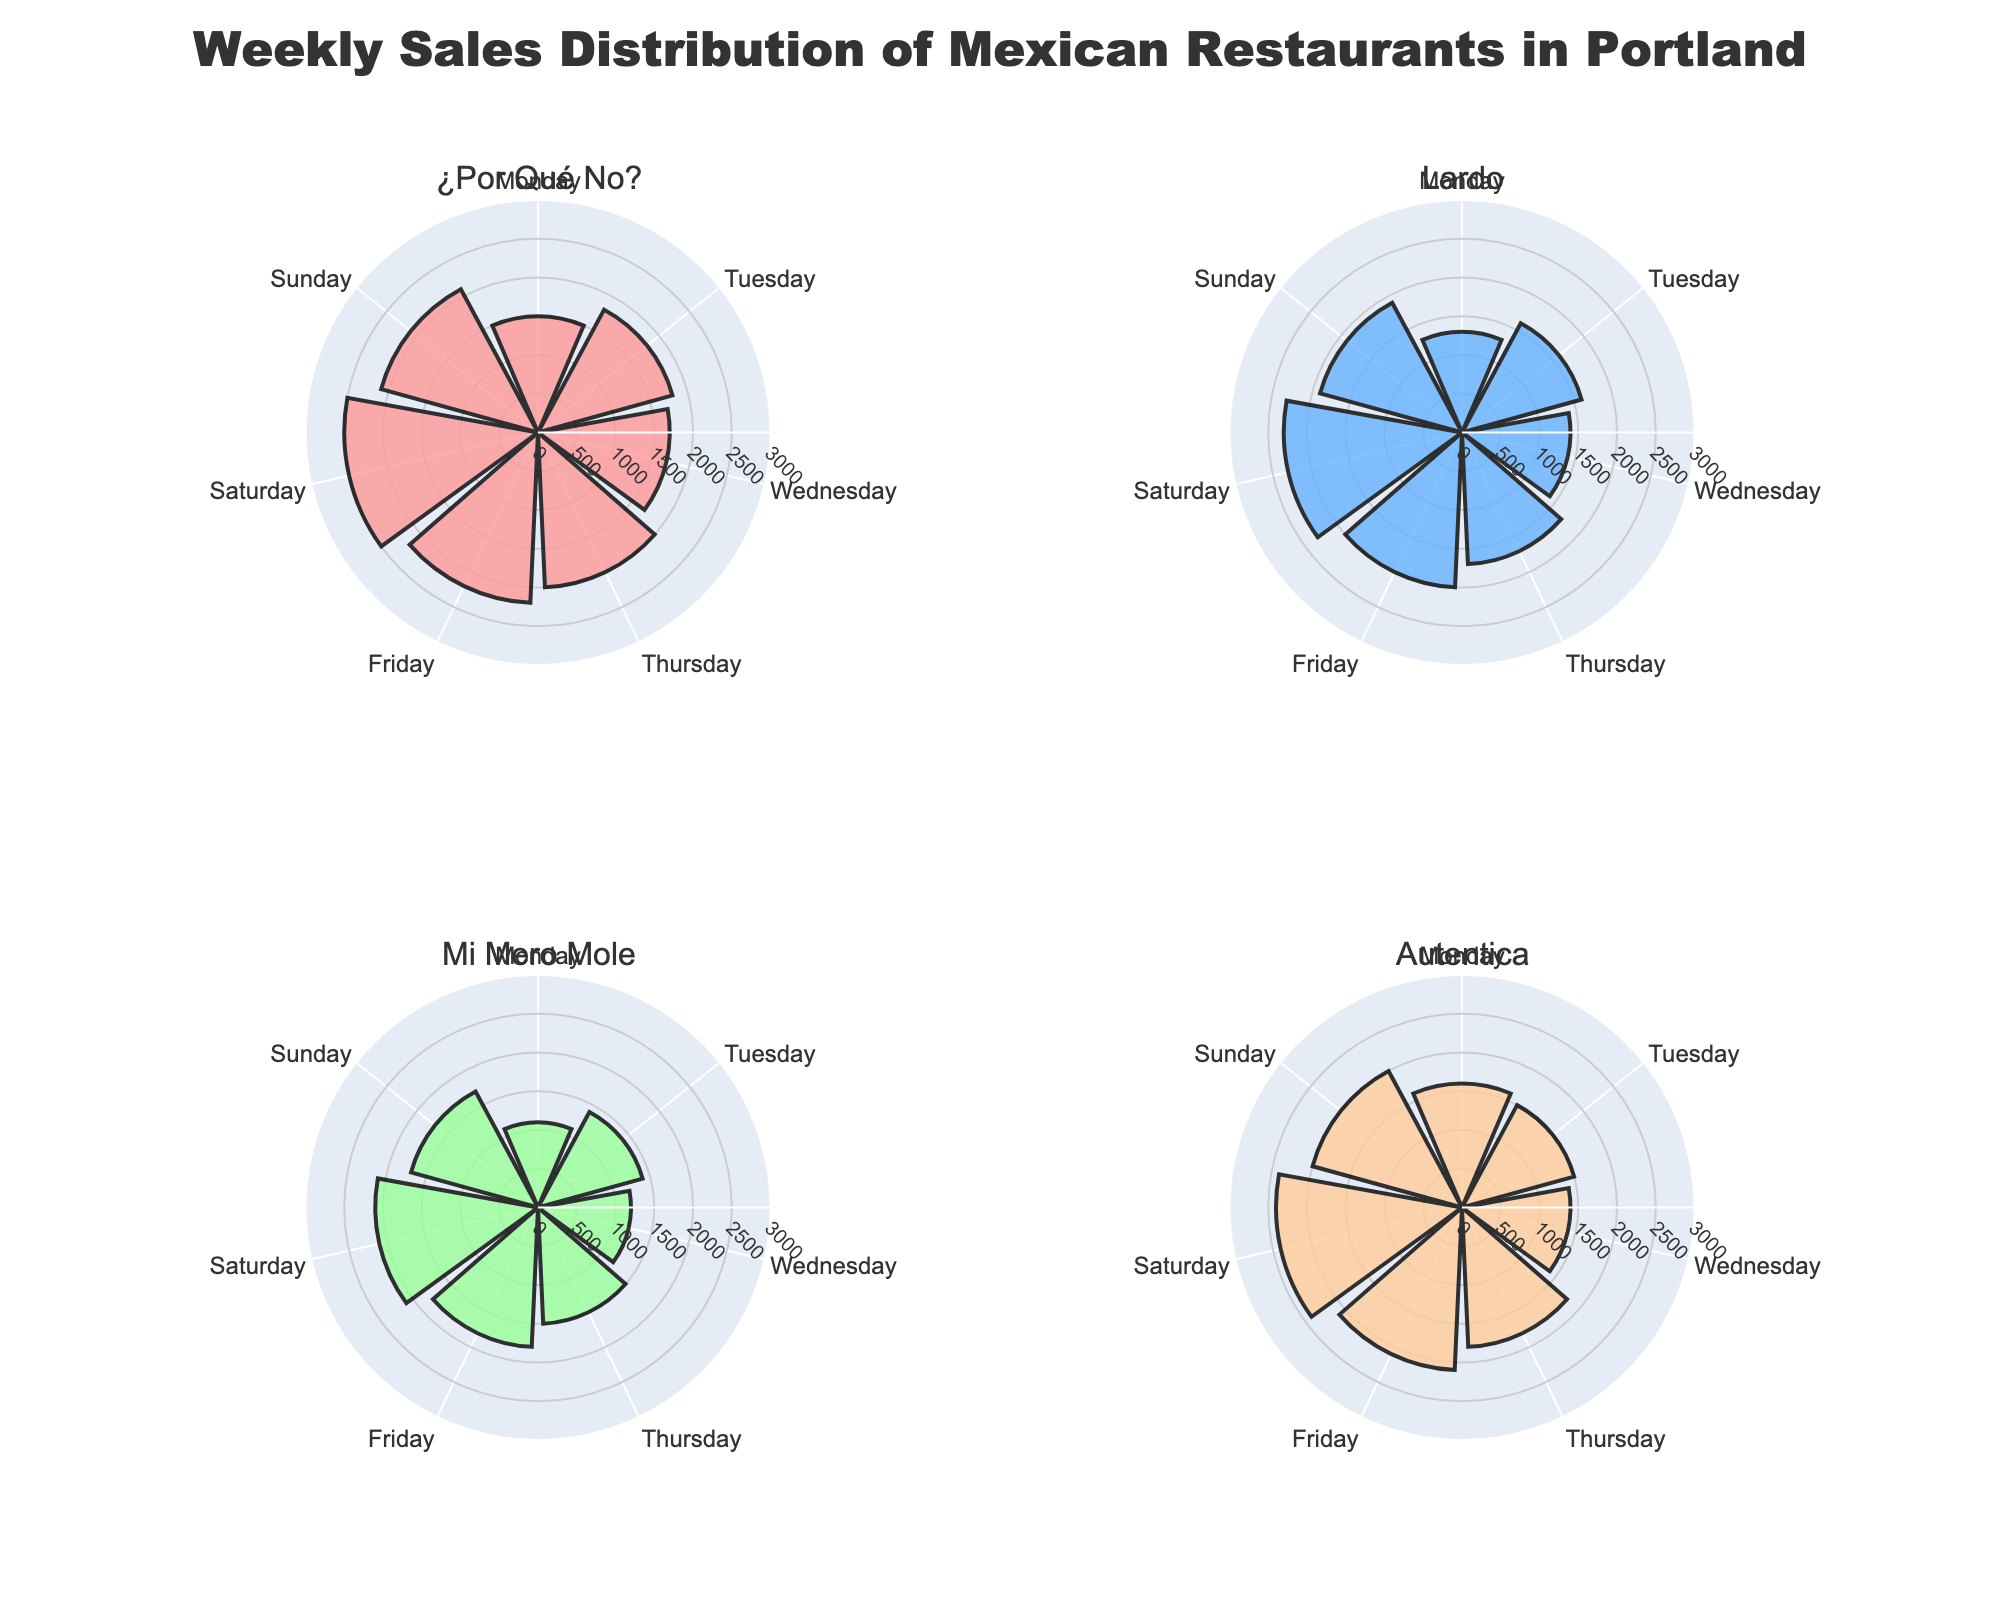What's the title of the figure? The title is usually displayed at the top of the figure. For this plot, it is "Weekly Sales Distribution of Mexican Restaurants in Portland".
Answer: Weekly Sales Distribution of Mexican Restaurants in Portland How many subplots are there in the figure? By counting the individual rose charts in the figure, we can see that there are four subplots, each representing a different restaurant.
Answer: Four Which restaurant has the highest sales on Saturday? We observe the bars for Saturday in each subplot. "¿Por Qué No?" has the highest bar on Saturday, indicating it has the highest sales on that day.
Answer: ¿Por Qué No? Which day has the lowest sales for "Mi Mero Mole"? Within the subplot for "Mi Mero Mole", we examine the bars for each day. The bar for Monday is the shortest, indicating it has the lowest sales.
Answer: Monday Compare the Sunday sales of "Lardo" and "Autentica". Which one is higher? We compare the Sunday bars in "Lardo" and "Autentica" subplots. "Autentica" has a taller bar on Sunday, indicating higher sales.
Answer: Autentica What is the total weekly sales of "¿Por Qué No?"? Sum the sales values for each day in the "¿Por Qué No?" subplot: 1500 + 1800 + 1700 + 2000 + 2200 + 2500 + 2100. The total is 13800.
Answer: 13800 Which cuisine type has the most consistent daily sales? Consistent sales can be identified by observing which subplot has bars of similar heights throughout the week. "Autentica" appears to have the most uniform bar heights, indicating consistent sales.
Answer: Autentica Which restaurant has the lowest sales on Tuesday? By looking at the Tuesday bars in each subplot, we see that "Autentica" has the shortest bar for Tuesday, indicating the lowest sales.
Answer: Autentica What is the range of weekly sales for "Mi Mero Mole"? The range is calculated by subtracting the lowest sale day from the highest sale day. For "Mi Mero Mole": highest (Saturday, 2100) minus lowest (Monday, 1100) equals 1000.
Answer: 1000 